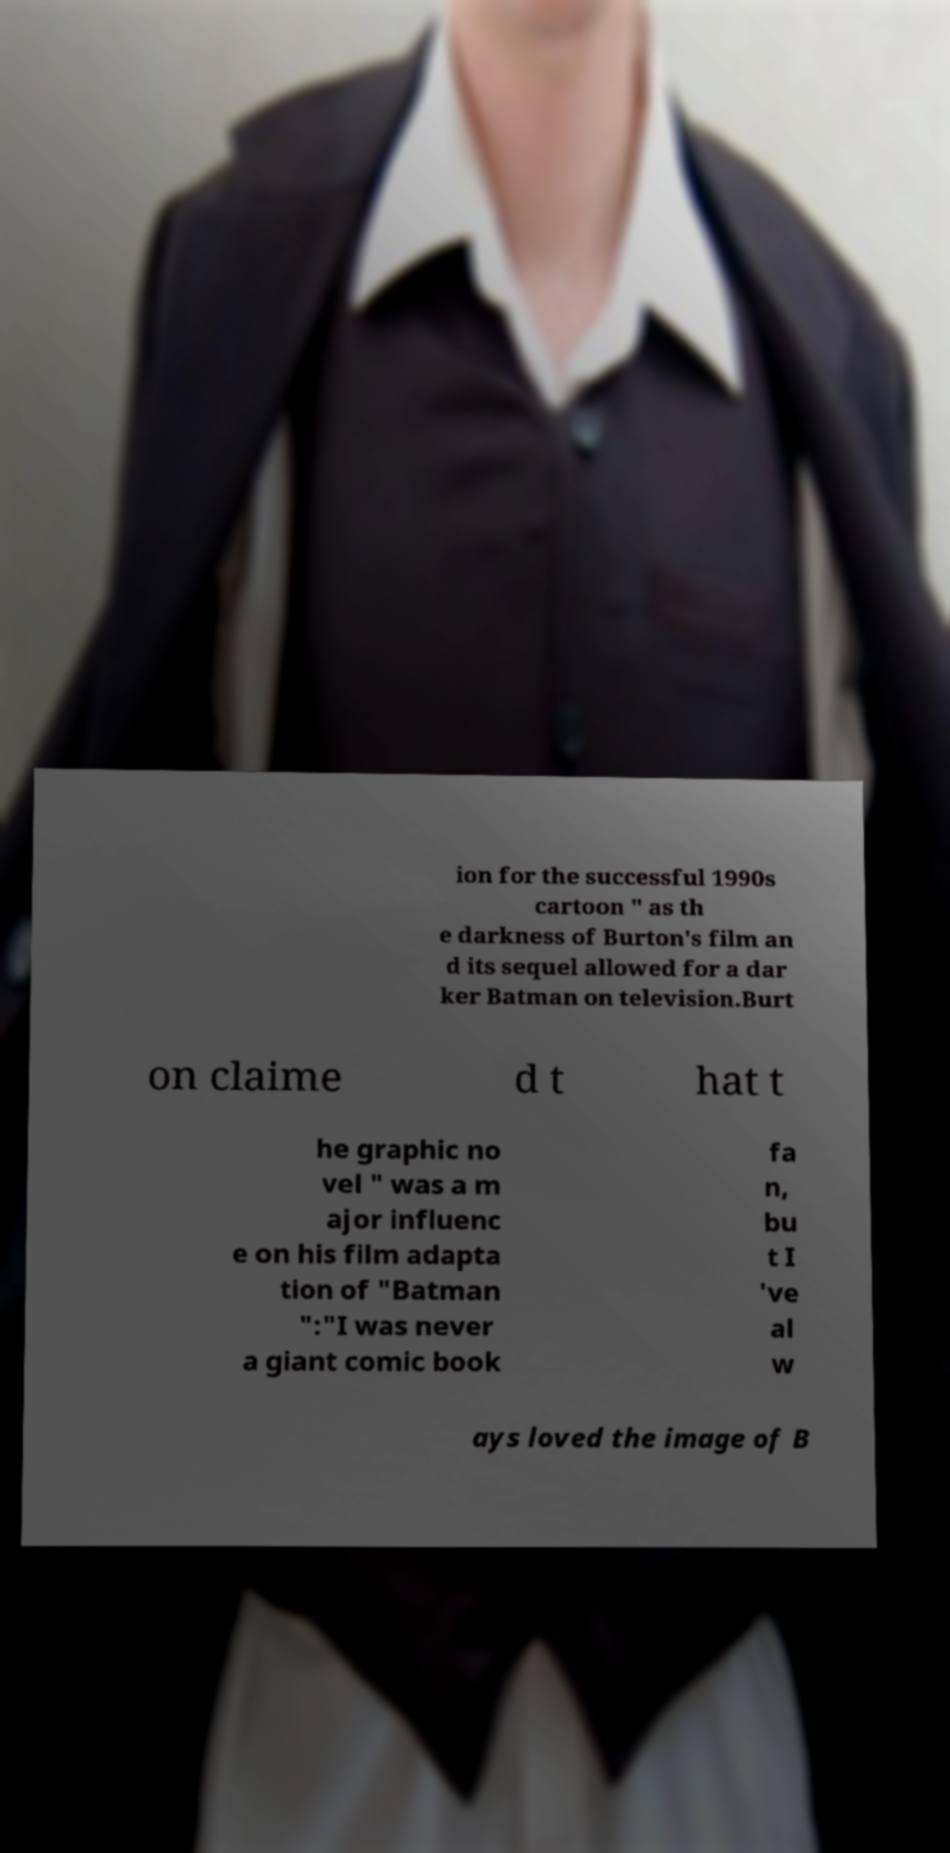For documentation purposes, I need the text within this image transcribed. Could you provide that? ion for the successful 1990s cartoon " as th e darkness of Burton's film an d its sequel allowed for a dar ker Batman on television.Burt on claime d t hat t he graphic no vel " was a m ajor influenc e on his film adapta tion of "Batman ":"I was never a giant comic book fa n, bu t I 've al w ays loved the image of B 